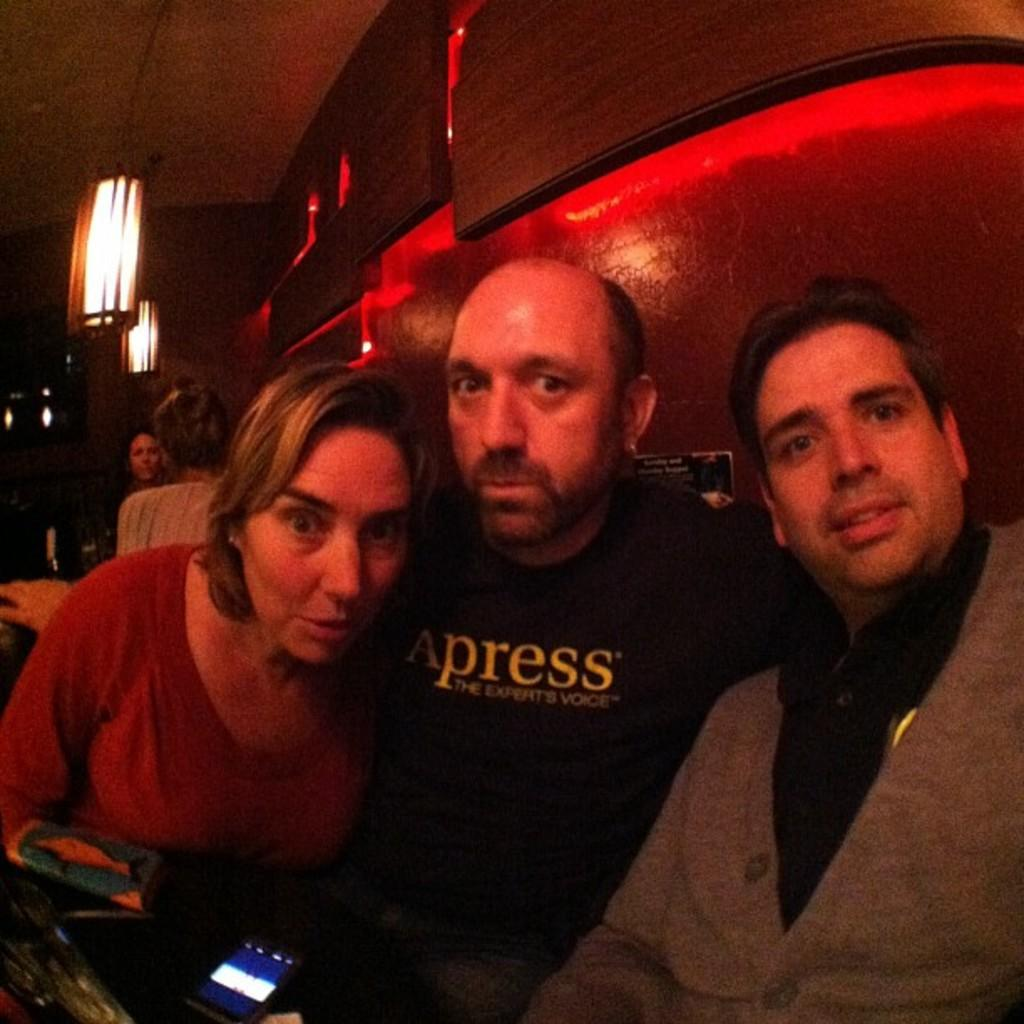Who or what can be seen in the image? There are people in the image. What is hanging from the top in the image? There are lights hanging from the top in the image. What type of lighting is present on the wall in the image? There is lighting on the wall in the image. Can you see a snake slithering on the wall in the image? No, there is no snake present in the image. Is the image taken during winter, as indicated by the presence of a tree with snow on its branches? There is no tree or snow visible in the image, so it cannot be determined if the image was taken during winter. 